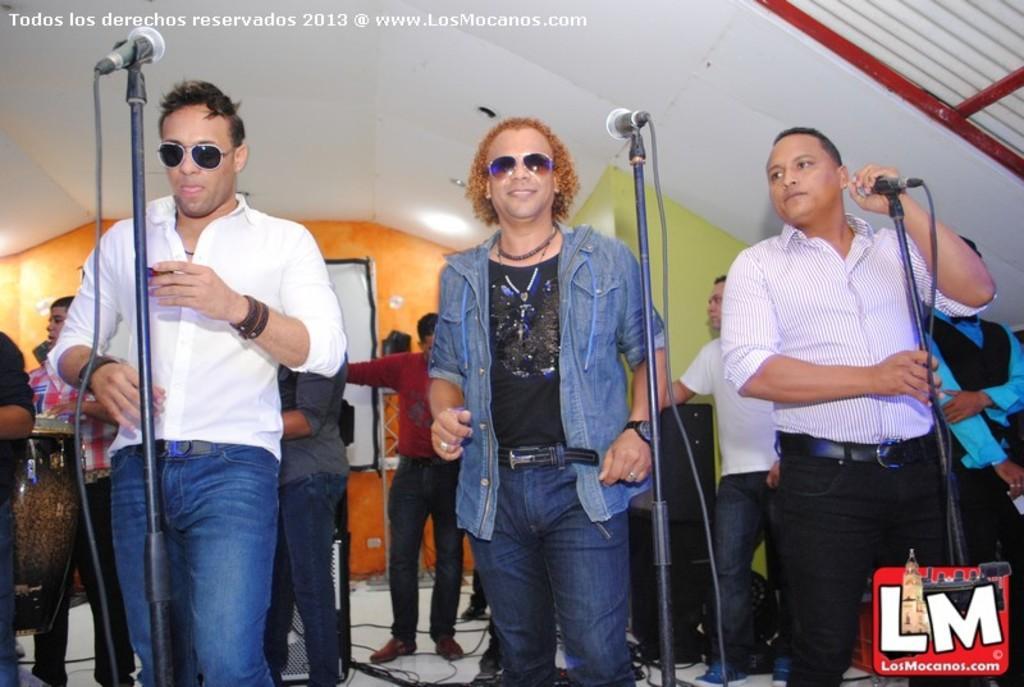Please provide a concise description of this image. This picture shows a group of people standing and we see three people in front of a microphone and a man holding a microphone in his hand 